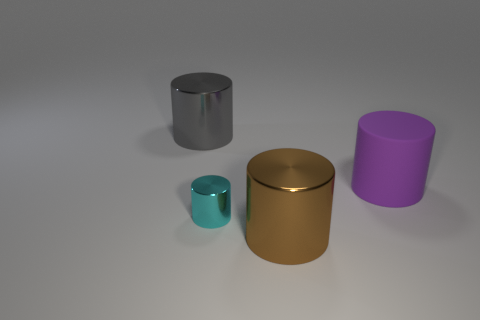Subtract all brown cylinders. How many cylinders are left? 3 Add 1 big blue things. How many objects exist? 5 Subtract all gray cylinders. How many cylinders are left? 3 Subtract 0 purple blocks. How many objects are left? 4 Subtract 1 cylinders. How many cylinders are left? 3 Subtract all cyan cylinders. Subtract all red spheres. How many cylinders are left? 3 Subtract all brown cubes. How many purple cylinders are left? 1 Subtract all tiny cyan objects. Subtract all cyan things. How many objects are left? 2 Add 1 cyan things. How many cyan things are left? 2 Add 4 metallic objects. How many metallic objects exist? 7 